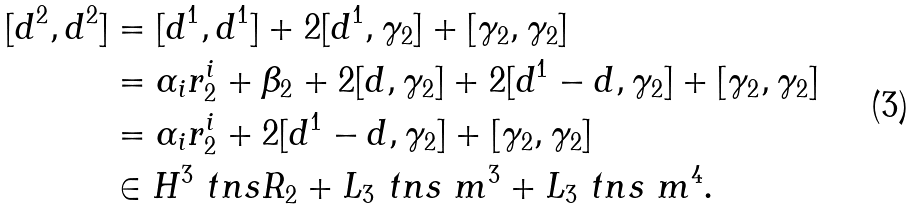<formula> <loc_0><loc_0><loc_500><loc_500>[ d ^ { 2 } , d ^ { 2 } ] & = [ d ^ { 1 } , d ^ { 1 } ] + 2 [ d ^ { 1 } , \gamma _ { 2 } ] + [ \gamma _ { 2 } , \gamma _ { 2 } ] \\ & = \alpha _ { i } r ^ { i } _ { 2 } + \beta _ { 2 } + 2 [ d , \gamma _ { 2 } ] + 2 [ d ^ { 1 } - d , \gamma _ { 2 } ] + [ \gamma _ { 2 } , \gamma _ { 2 } ] \\ & = \alpha _ { i } r ^ { i } _ { 2 } + 2 [ d ^ { 1 } - d , \gamma _ { 2 } ] + [ \gamma _ { 2 } , \gamma _ { 2 } ] \\ & \in H ^ { 3 } \ t n s R _ { 2 } + L _ { 3 } \ t n s \ m ^ { 3 } + L _ { 3 } \ t n s \ m ^ { 4 } .</formula> 